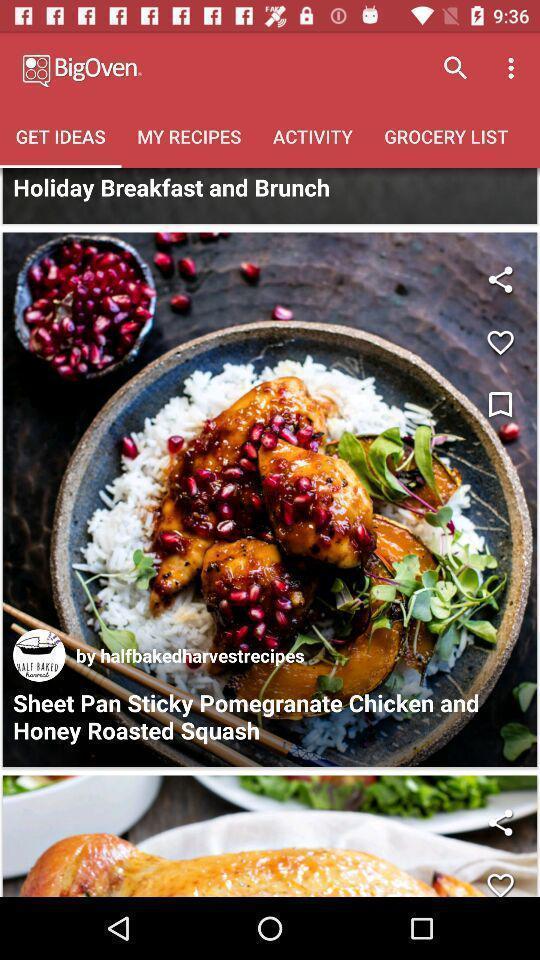Describe the visual elements of this screenshot. Screen page of a food application. 